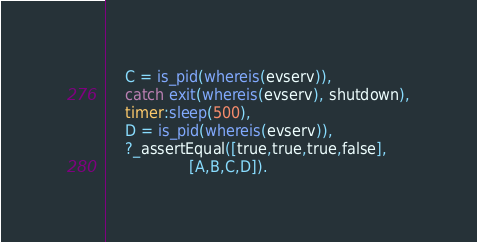Convert code to text. <code><loc_0><loc_0><loc_500><loc_500><_Erlang_>    C = is_pid(whereis(evserv)),
    catch exit(whereis(evserv), shutdown),
    timer:sleep(500),
    D = is_pid(whereis(evserv)),
    ?_assertEqual([true,true,true,false],
                  [A,B,C,D]).

</code> 